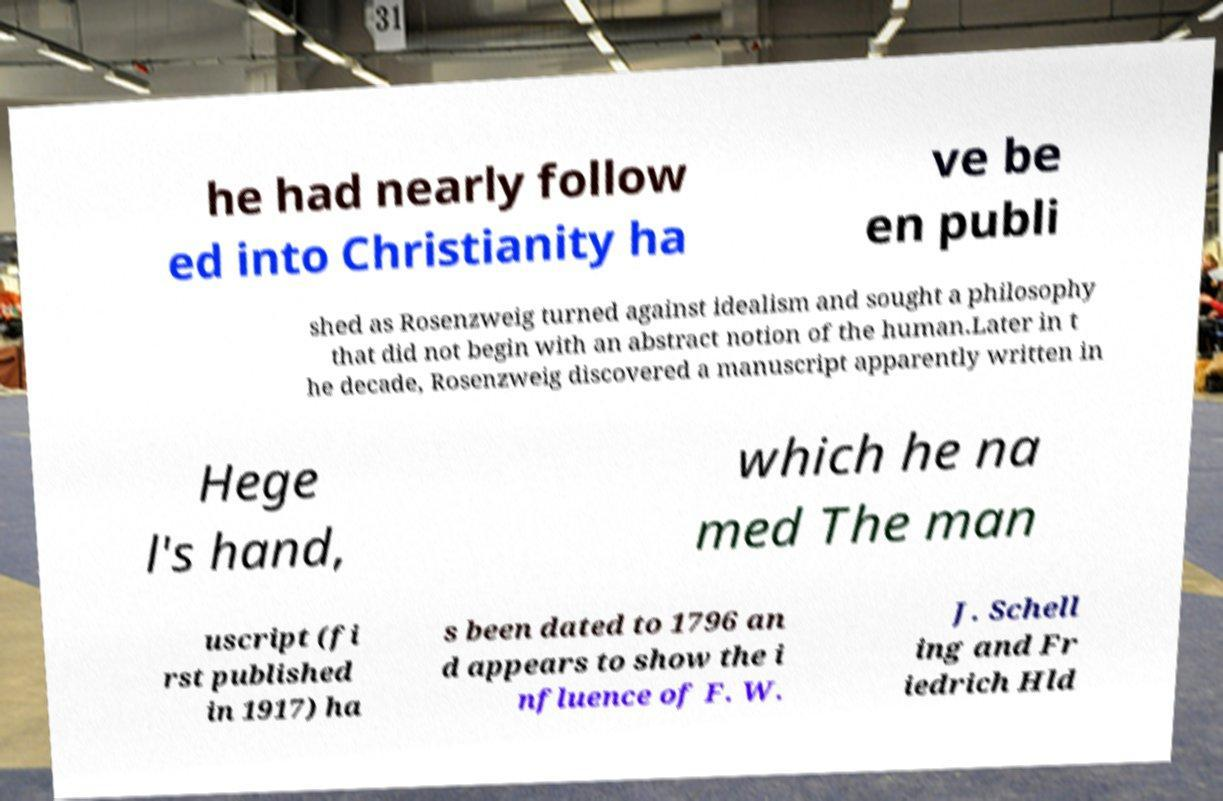I need the written content from this picture converted into text. Can you do that? he had nearly follow ed into Christianity ha ve be en publi shed as Rosenzweig turned against idealism and sought a philosophy that did not begin with an abstract notion of the human.Later in t he decade, Rosenzweig discovered a manuscript apparently written in Hege l's hand, which he na med The man uscript (fi rst published in 1917) ha s been dated to 1796 an d appears to show the i nfluence of F. W. J. Schell ing and Fr iedrich Hld 